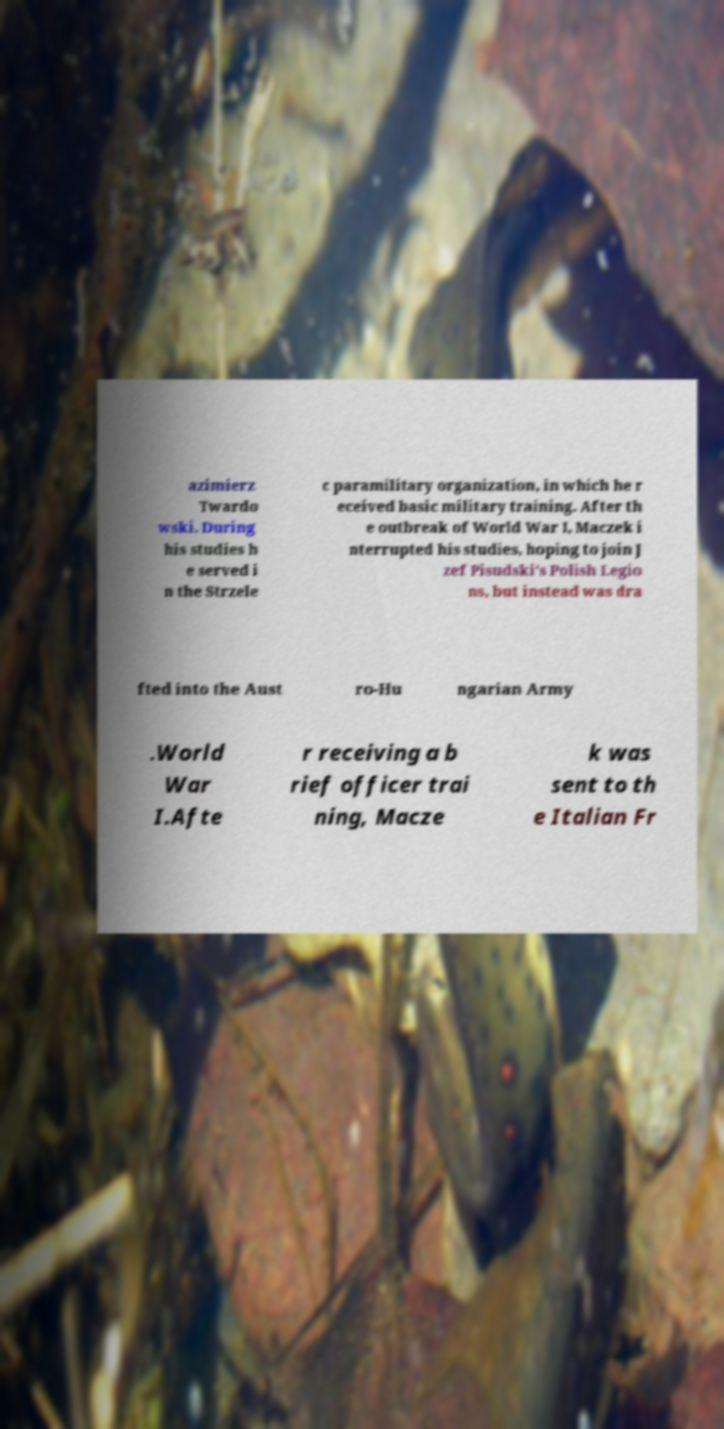Can you read and provide the text displayed in the image?This photo seems to have some interesting text. Can you extract and type it out for me? azimierz Twardo wski. During his studies h e served i n the Strzele c paramilitary organization, in which he r eceived basic military training. After th e outbreak of World War I, Maczek i nterrupted his studies, hoping to join J zef Pisudski's Polish Legio ns, but instead was dra fted into the Aust ro-Hu ngarian Army .World War I.Afte r receiving a b rief officer trai ning, Macze k was sent to th e Italian Fr 